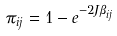<formula> <loc_0><loc_0><loc_500><loc_500>\pi _ { i j } = 1 - e ^ { - 2 J \beta _ { i j } }</formula> 